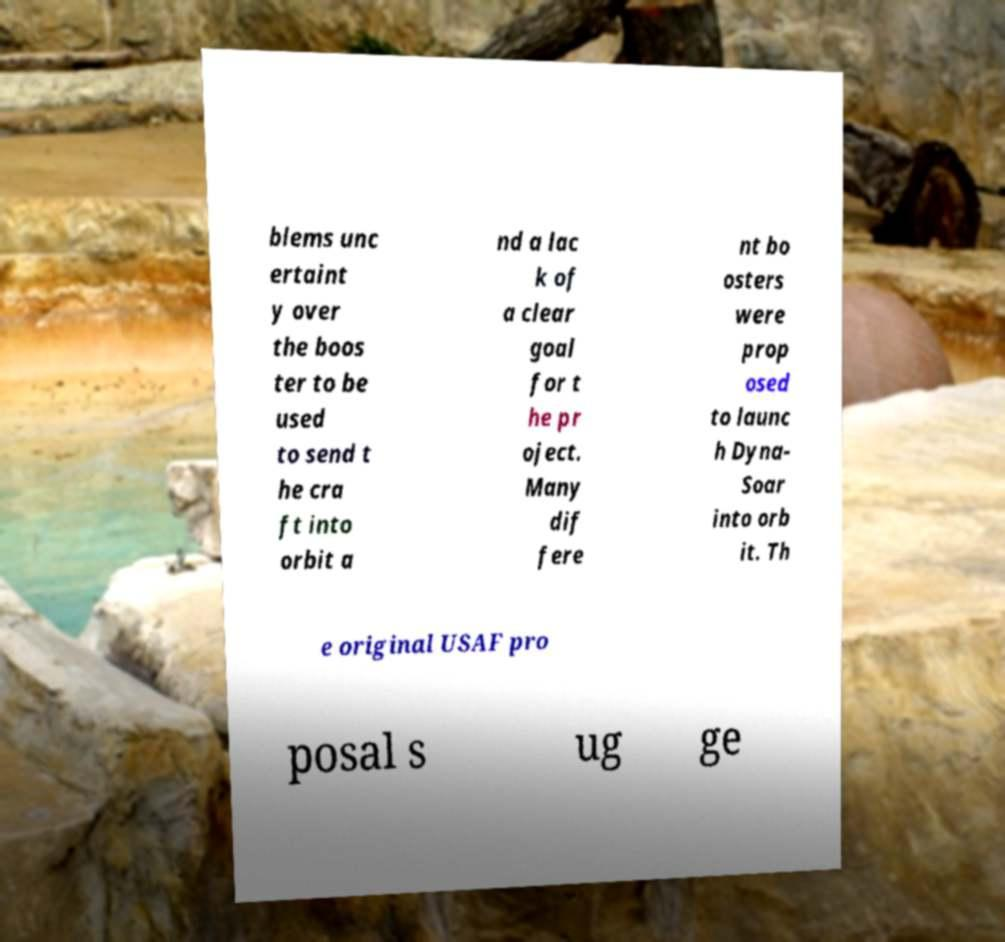Please identify and transcribe the text found in this image. blems unc ertaint y over the boos ter to be used to send t he cra ft into orbit a nd a lac k of a clear goal for t he pr oject. Many dif fere nt bo osters were prop osed to launc h Dyna- Soar into orb it. Th e original USAF pro posal s ug ge 